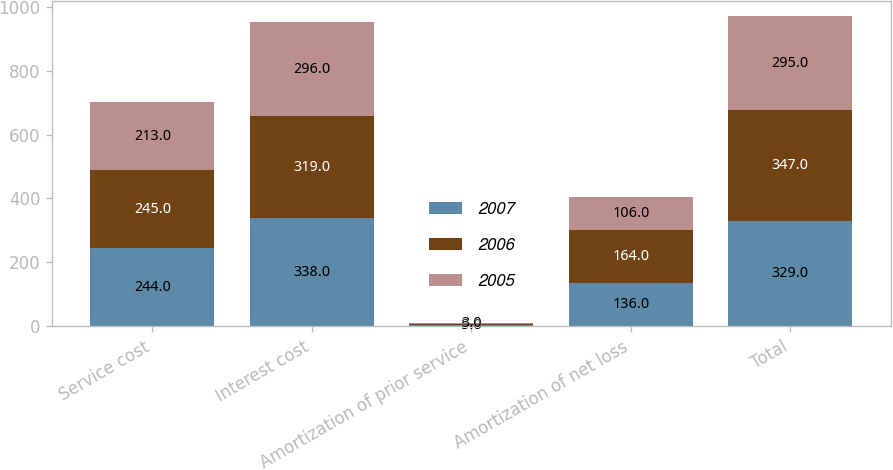Convert chart. <chart><loc_0><loc_0><loc_500><loc_500><stacked_bar_chart><ecel><fcel>Service cost<fcel>Interest cost<fcel>Amortization of prior service<fcel>Amortization of net loss<fcel>Total<nl><fcel>2007<fcel>244<fcel>338<fcel>5<fcel>136<fcel>329<nl><fcel>2006<fcel>245<fcel>319<fcel>3<fcel>164<fcel>347<nl><fcel>2005<fcel>213<fcel>296<fcel>3<fcel>106<fcel>295<nl></chart> 